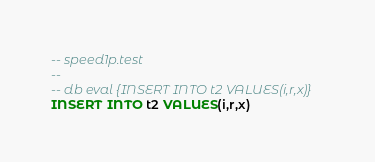<code> <loc_0><loc_0><loc_500><loc_500><_SQL_>-- speed1p.test
-- 
-- db eval {INSERT INTO t2 VALUES(i,r,x)}
INSERT INTO t2 VALUES(i,r,x)
</code> 